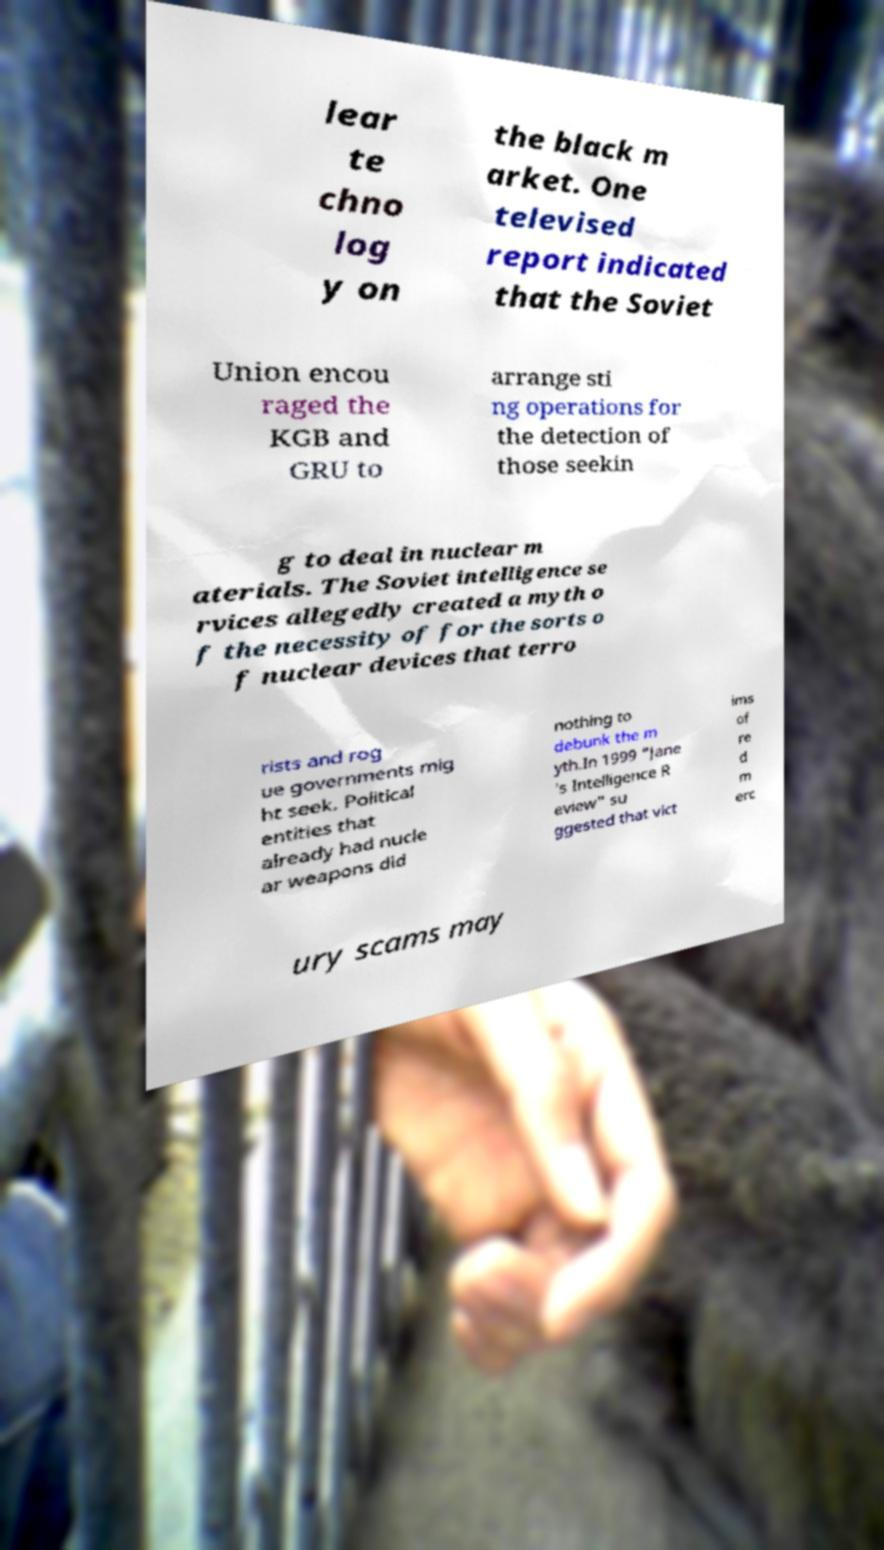What messages or text are displayed in this image? I need them in a readable, typed format. lear te chno log y on the black m arket. One televised report indicated that the Soviet Union encou raged the KGB and GRU to arrange sti ng operations for the detection of those seekin g to deal in nuclear m aterials. The Soviet intelligence se rvices allegedly created a myth o f the necessity of for the sorts o f nuclear devices that terro rists and rog ue governments mig ht seek. Political entities that already had nucle ar weapons did nothing to debunk the m yth.In 1999 "Jane 's Intelligence R eview" su ggested that vict ims of re d m erc ury scams may 